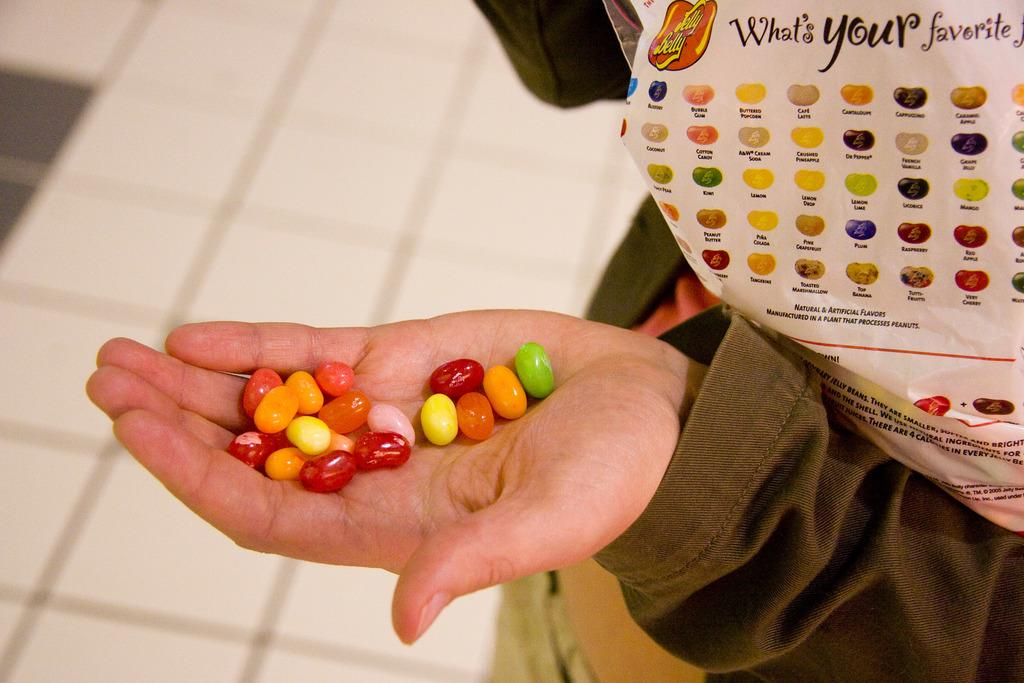What is the person holding in their hand in the image? There are colorful objects in the person's hand. Can you describe the overall quality of the image? The image is blurred. What type of root can be seen growing from the chain in the image? There is no root or chain present in the image. What type of airplane is visible in the background of the image? There is no airplane visible in the image; it is focused on a person holding colorful objects. 